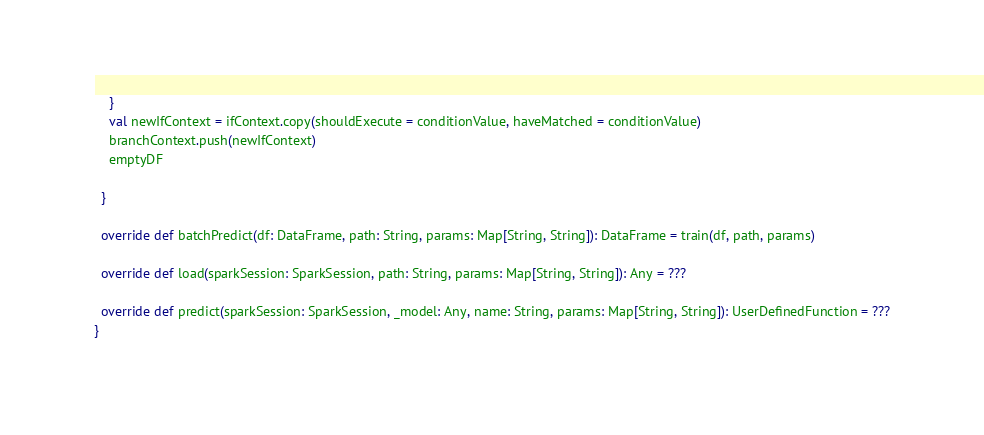Convert code to text. <code><loc_0><loc_0><loc_500><loc_500><_Scala_>    }
    val newIfContext = ifContext.copy(shouldExecute = conditionValue, haveMatched = conditionValue)
    branchContext.push(newIfContext)
    emptyDF

  }

  override def batchPredict(df: DataFrame, path: String, params: Map[String, String]): DataFrame = train(df, path, params)

  override def load(sparkSession: SparkSession, path: String, params: Map[String, String]): Any = ???

  override def predict(sparkSession: SparkSession, _model: Any, name: String, params: Map[String, String]): UserDefinedFunction = ???
}
</code> 